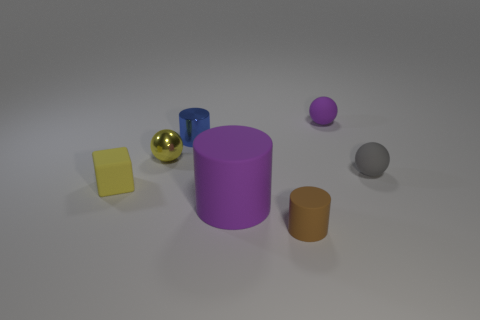Add 1 big objects. How many objects exist? 8 Subtract all cubes. How many objects are left? 6 Subtract all large purple matte things. Subtract all gray objects. How many objects are left? 5 Add 1 purple matte objects. How many purple matte objects are left? 3 Add 7 brown metallic balls. How many brown metallic balls exist? 7 Subtract 0 cyan cubes. How many objects are left? 7 